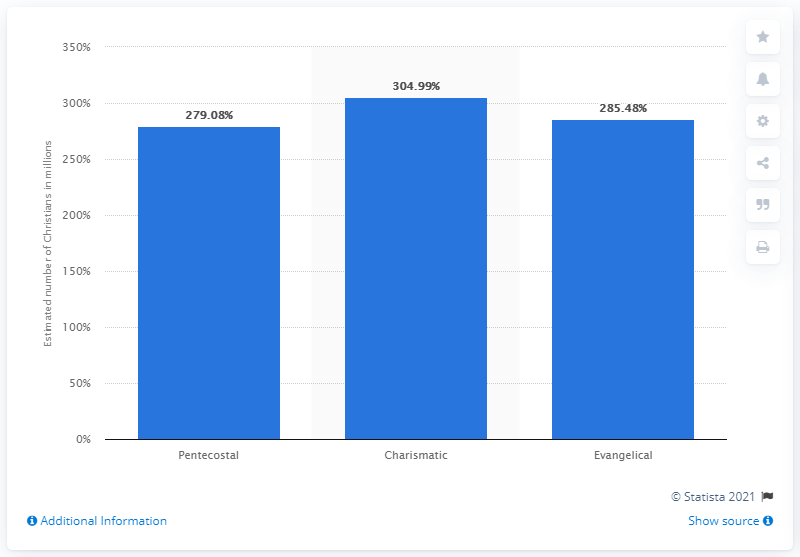List a handful of essential elements in this visual. In 2010, 304,99 million Christians identified with the Charismatic movement. 